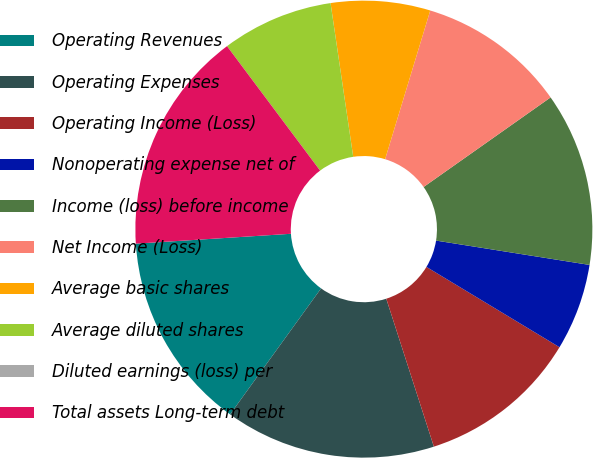Convert chart to OTSL. <chart><loc_0><loc_0><loc_500><loc_500><pie_chart><fcel>Operating Revenues<fcel>Operating Expenses<fcel>Operating Income (Loss)<fcel>Nonoperating expense net of<fcel>Income (loss) before income<fcel>Net Income (Loss)<fcel>Average basic shares<fcel>Average diluted shares<fcel>Diluted earnings (loss) per<fcel>Total assets Long-term debt<nl><fcel>14.03%<fcel>14.91%<fcel>11.4%<fcel>6.14%<fcel>12.28%<fcel>10.53%<fcel>7.02%<fcel>7.89%<fcel>0.0%<fcel>15.79%<nl></chart> 